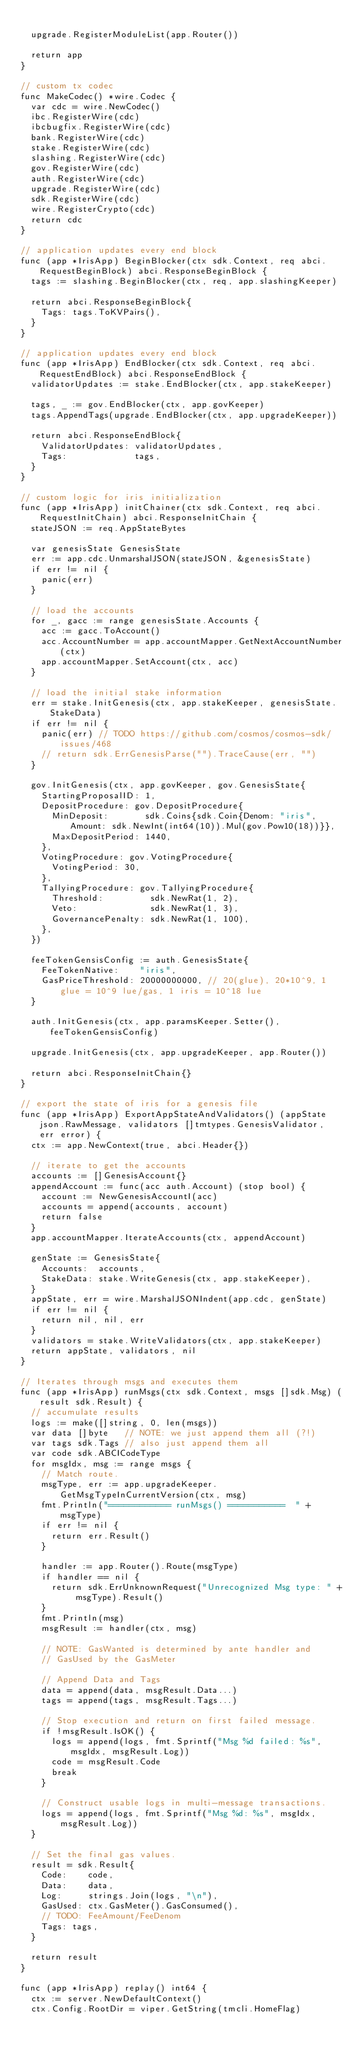<code> <loc_0><loc_0><loc_500><loc_500><_Go_>
	upgrade.RegisterModuleList(app.Router())

	return app
}

// custom tx codec
func MakeCodec() *wire.Codec {
	var cdc = wire.NewCodec()
	ibc.RegisterWire(cdc)
	ibcbugfix.RegisterWire(cdc)
	bank.RegisterWire(cdc)
	stake.RegisterWire(cdc)
	slashing.RegisterWire(cdc)
	gov.RegisterWire(cdc)
	auth.RegisterWire(cdc)
	upgrade.RegisterWire(cdc)
	sdk.RegisterWire(cdc)
	wire.RegisterCrypto(cdc)
	return cdc
}

// application updates every end block
func (app *IrisApp) BeginBlocker(ctx sdk.Context, req abci.RequestBeginBlock) abci.ResponseBeginBlock {
	tags := slashing.BeginBlocker(ctx, req, app.slashingKeeper)

	return abci.ResponseBeginBlock{
		Tags: tags.ToKVPairs(),
	}
}

// application updates every end block
func (app *IrisApp) EndBlocker(ctx sdk.Context, req abci.RequestEndBlock) abci.ResponseEndBlock {
	validatorUpdates := stake.EndBlocker(ctx, app.stakeKeeper)

	tags, _ := gov.EndBlocker(ctx, app.govKeeper)
	tags.AppendTags(upgrade.EndBlocker(ctx, app.upgradeKeeper))

	return abci.ResponseEndBlock{
		ValidatorUpdates: validatorUpdates,
		Tags:             tags,
	}
}

// custom logic for iris initialization
func (app *IrisApp) initChainer(ctx sdk.Context, req abci.RequestInitChain) abci.ResponseInitChain {
	stateJSON := req.AppStateBytes

	var genesisState GenesisState
	err := app.cdc.UnmarshalJSON(stateJSON, &genesisState)
	if err != nil {
		panic(err)
	}

	// load the accounts
	for _, gacc := range genesisState.Accounts {
		acc := gacc.ToAccount()
		acc.AccountNumber = app.accountMapper.GetNextAccountNumber(ctx)
		app.accountMapper.SetAccount(ctx, acc)
	}

	// load the initial stake information
	err = stake.InitGenesis(ctx, app.stakeKeeper, genesisState.StakeData)
	if err != nil {
		panic(err) // TODO https://github.com/cosmos/cosmos-sdk/issues/468
		// return sdk.ErrGenesisParse("").TraceCause(err, "")
	}

	gov.InitGenesis(ctx, app.govKeeper, gov.GenesisState{
		StartingProposalID: 1,
		DepositProcedure: gov.DepositProcedure{
			MinDeposit:       sdk.Coins{sdk.Coin{Denom: "iris", Amount: sdk.NewInt(int64(10)).Mul(gov.Pow10(18))}},
			MaxDepositPeriod: 1440,
		},
		VotingProcedure: gov.VotingProcedure{
			VotingPeriod: 30,
		},
		TallyingProcedure: gov.TallyingProcedure{
			Threshold:         sdk.NewRat(1, 2),
			Veto:              sdk.NewRat(1, 3),
			GovernancePenalty: sdk.NewRat(1, 100),
		},
	})

	feeTokenGensisConfig := auth.GenesisState{
		FeeTokenNative:    "iris",
		GasPriceThreshold: 20000000000, // 20(glue), 20*10^9, 1 glue = 10^9 lue/gas, 1 iris = 10^18 lue
	}

	auth.InitGenesis(ctx, app.paramsKeeper.Setter(), feeTokenGensisConfig)

	upgrade.InitGenesis(ctx, app.upgradeKeeper, app.Router())

	return abci.ResponseInitChain{}
}

// export the state of iris for a genesis file
func (app *IrisApp) ExportAppStateAndValidators() (appState json.RawMessage, validators []tmtypes.GenesisValidator, err error) {
	ctx := app.NewContext(true, abci.Header{})

	// iterate to get the accounts
	accounts := []GenesisAccount{}
	appendAccount := func(acc auth.Account) (stop bool) {
		account := NewGenesisAccountI(acc)
		accounts = append(accounts, account)
		return false
	}
	app.accountMapper.IterateAccounts(ctx, appendAccount)

	genState := GenesisState{
		Accounts:  accounts,
		StakeData: stake.WriteGenesis(ctx, app.stakeKeeper),
	}
	appState, err = wire.MarshalJSONIndent(app.cdc, genState)
	if err != nil {
		return nil, nil, err
	}
	validators = stake.WriteValidators(ctx, app.stakeKeeper)
	return appState, validators, nil
}

// Iterates through msgs and executes them
func (app *IrisApp) runMsgs(ctx sdk.Context, msgs []sdk.Msg) (result sdk.Result) {
	// accumulate results
	logs := make([]string, 0, len(msgs))
	var data []byte   // NOTE: we just append them all (?!)
	var tags sdk.Tags // also just append them all
	var code sdk.ABCICodeType
	for msgIdx, msg := range msgs {
		// Match route.
		msgType, err := app.upgradeKeeper.GetMsgTypeInCurrentVersion(ctx, msg)
		fmt.Println("============ runMsgs() ===========  " + msgType)
		if err != nil {
			return err.Result()
		}

		handler := app.Router().Route(msgType)
		if handler == nil {
			return sdk.ErrUnknownRequest("Unrecognized Msg type: " + msgType).Result()
		}
		fmt.Println(msg)
		msgResult := handler(ctx, msg)

		// NOTE: GasWanted is determined by ante handler and
		// GasUsed by the GasMeter

		// Append Data and Tags
		data = append(data, msgResult.Data...)
		tags = append(tags, msgResult.Tags...)

		// Stop execution and return on first failed message.
		if !msgResult.IsOK() {
			logs = append(logs, fmt.Sprintf("Msg %d failed: %s", msgIdx, msgResult.Log))
			code = msgResult.Code
			break
		}

		// Construct usable logs in multi-message transactions.
		logs = append(logs, fmt.Sprintf("Msg %d: %s", msgIdx, msgResult.Log))
	}

	// Set the final gas values.
	result = sdk.Result{
		Code:    code,
		Data:    data,
		Log:     strings.Join(logs, "\n"),
		GasUsed: ctx.GasMeter().GasConsumed(),
		// TODO: FeeAmount/FeeDenom
		Tags: tags,
	}

	return result
}

func (app *IrisApp) replay() int64 {
	ctx := server.NewDefaultContext()
	ctx.Config.RootDir = viper.GetString(tmcli.HomeFlag)</code> 